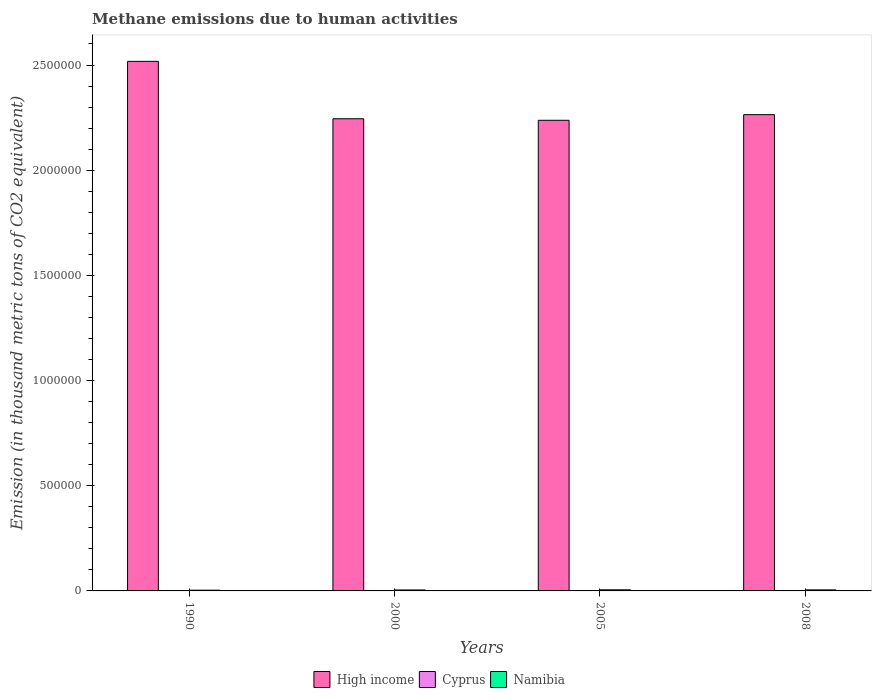How many different coloured bars are there?
Make the answer very short. 3. Are the number of bars per tick equal to the number of legend labels?
Keep it short and to the point. Yes. Are the number of bars on each tick of the X-axis equal?
Give a very brief answer. Yes. What is the label of the 4th group of bars from the left?
Your answer should be compact. 2008. In how many cases, is the number of bars for a given year not equal to the number of legend labels?
Provide a short and direct response. 0. What is the amount of methane emitted in Namibia in 2008?
Give a very brief answer. 4941.9. Across all years, what is the maximum amount of methane emitted in High income?
Your answer should be compact. 2.52e+06. Across all years, what is the minimum amount of methane emitted in High income?
Ensure brevity in your answer.  2.24e+06. In which year was the amount of methane emitted in Namibia minimum?
Provide a succinct answer. 1990. What is the total amount of methane emitted in Cyprus in the graph?
Make the answer very short. 2243.3. What is the difference between the amount of methane emitted in Namibia in 1990 and that in 2008?
Provide a succinct answer. -1388.4. What is the difference between the amount of methane emitted in Namibia in 2000 and the amount of methane emitted in Cyprus in 1990?
Keep it short and to the point. 4140.4. What is the average amount of methane emitted in Namibia per year?
Your answer should be very brief. 4582.1. In the year 2008, what is the difference between the amount of methane emitted in Cyprus and amount of methane emitted in High income?
Give a very brief answer. -2.26e+06. In how many years, is the amount of methane emitted in Namibia greater than 500000 thousand metric tons?
Make the answer very short. 0. What is the ratio of the amount of methane emitted in High income in 2000 to that in 2008?
Provide a succinct answer. 0.99. Is the amount of methane emitted in High income in 2000 less than that in 2008?
Ensure brevity in your answer.  Yes. What is the difference between the highest and the second highest amount of methane emitted in Cyprus?
Make the answer very short. 4.4. What is the difference between the highest and the lowest amount of methane emitted in Cyprus?
Offer a terse response. 177.3. In how many years, is the amount of methane emitted in High income greater than the average amount of methane emitted in High income taken over all years?
Give a very brief answer. 1. What does the 2nd bar from the left in 2008 represents?
Your response must be concise. Cyprus. What does the 3rd bar from the right in 2005 represents?
Provide a succinct answer. High income. How many bars are there?
Keep it short and to the point. 12. Are all the bars in the graph horizontal?
Provide a succinct answer. No. Are the values on the major ticks of Y-axis written in scientific E-notation?
Make the answer very short. No. Where does the legend appear in the graph?
Keep it short and to the point. Bottom center. How are the legend labels stacked?
Your answer should be very brief. Horizontal. What is the title of the graph?
Ensure brevity in your answer.  Methane emissions due to human activities. Does "Cabo Verde" appear as one of the legend labels in the graph?
Provide a succinct answer. No. What is the label or title of the Y-axis?
Offer a terse response. Emission (in thousand metric tons of CO2 equivalent). What is the Emission (in thousand metric tons of CO2 equivalent) of High income in 1990?
Your response must be concise. 2.52e+06. What is the Emission (in thousand metric tons of CO2 equivalent) of Cyprus in 1990?
Your response must be concise. 441.3. What is the Emission (in thousand metric tons of CO2 equivalent) in Namibia in 1990?
Ensure brevity in your answer.  3553.5. What is the Emission (in thousand metric tons of CO2 equivalent) of High income in 2000?
Your answer should be very brief. 2.24e+06. What is the Emission (in thousand metric tons of CO2 equivalent) in Cyprus in 2000?
Your answer should be compact. 569.2. What is the Emission (in thousand metric tons of CO2 equivalent) of Namibia in 2000?
Offer a terse response. 4581.7. What is the Emission (in thousand metric tons of CO2 equivalent) of High income in 2005?
Ensure brevity in your answer.  2.24e+06. What is the Emission (in thousand metric tons of CO2 equivalent) of Cyprus in 2005?
Make the answer very short. 618.6. What is the Emission (in thousand metric tons of CO2 equivalent) of Namibia in 2005?
Your answer should be very brief. 5251.3. What is the Emission (in thousand metric tons of CO2 equivalent) of High income in 2008?
Your answer should be compact. 2.26e+06. What is the Emission (in thousand metric tons of CO2 equivalent) of Cyprus in 2008?
Offer a terse response. 614.2. What is the Emission (in thousand metric tons of CO2 equivalent) in Namibia in 2008?
Provide a short and direct response. 4941.9. Across all years, what is the maximum Emission (in thousand metric tons of CO2 equivalent) of High income?
Offer a very short reply. 2.52e+06. Across all years, what is the maximum Emission (in thousand metric tons of CO2 equivalent) of Cyprus?
Your answer should be very brief. 618.6. Across all years, what is the maximum Emission (in thousand metric tons of CO2 equivalent) in Namibia?
Make the answer very short. 5251.3. Across all years, what is the minimum Emission (in thousand metric tons of CO2 equivalent) of High income?
Provide a short and direct response. 2.24e+06. Across all years, what is the minimum Emission (in thousand metric tons of CO2 equivalent) in Cyprus?
Offer a terse response. 441.3. Across all years, what is the minimum Emission (in thousand metric tons of CO2 equivalent) of Namibia?
Give a very brief answer. 3553.5. What is the total Emission (in thousand metric tons of CO2 equivalent) of High income in the graph?
Your answer should be very brief. 9.26e+06. What is the total Emission (in thousand metric tons of CO2 equivalent) in Cyprus in the graph?
Your answer should be compact. 2243.3. What is the total Emission (in thousand metric tons of CO2 equivalent) in Namibia in the graph?
Keep it short and to the point. 1.83e+04. What is the difference between the Emission (in thousand metric tons of CO2 equivalent) in High income in 1990 and that in 2000?
Provide a short and direct response. 2.73e+05. What is the difference between the Emission (in thousand metric tons of CO2 equivalent) in Cyprus in 1990 and that in 2000?
Offer a very short reply. -127.9. What is the difference between the Emission (in thousand metric tons of CO2 equivalent) in Namibia in 1990 and that in 2000?
Make the answer very short. -1028.2. What is the difference between the Emission (in thousand metric tons of CO2 equivalent) in High income in 1990 and that in 2005?
Give a very brief answer. 2.80e+05. What is the difference between the Emission (in thousand metric tons of CO2 equivalent) in Cyprus in 1990 and that in 2005?
Offer a very short reply. -177.3. What is the difference between the Emission (in thousand metric tons of CO2 equivalent) in Namibia in 1990 and that in 2005?
Offer a very short reply. -1697.8. What is the difference between the Emission (in thousand metric tons of CO2 equivalent) of High income in 1990 and that in 2008?
Provide a succinct answer. 2.53e+05. What is the difference between the Emission (in thousand metric tons of CO2 equivalent) of Cyprus in 1990 and that in 2008?
Your response must be concise. -172.9. What is the difference between the Emission (in thousand metric tons of CO2 equivalent) in Namibia in 1990 and that in 2008?
Provide a short and direct response. -1388.4. What is the difference between the Emission (in thousand metric tons of CO2 equivalent) of High income in 2000 and that in 2005?
Ensure brevity in your answer.  7311.3. What is the difference between the Emission (in thousand metric tons of CO2 equivalent) of Cyprus in 2000 and that in 2005?
Keep it short and to the point. -49.4. What is the difference between the Emission (in thousand metric tons of CO2 equivalent) of Namibia in 2000 and that in 2005?
Offer a very short reply. -669.6. What is the difference between the Emission (in thousand metric tons of CO2 equivalent) in High income in 2000 and that in 2008?
Provide a short and direct response. -1.95e+04. What is the difference between the Emission (in thousand metric tons of CO2 equivalent) in Cyprus in 2000 and that in 2008?
Your response must be concise. -45. What is the difference between the Emission (in thousand metric tons of CO2 equivalent) in Namibia in 2000 and that in 2008?
Keep it short and to the point. -360.2. What is the difference between the Emission (in thousand metric tons of CO2 equivalent) in High income in 2005 and that in 2008?
Provide a short and direct response. -2.68e+04. What is the difference between the Emission (in thousand metric tons of CO2 equivalent) in Cyprus in 2005 and that in 2008?
Offer a terse response. 4.4. What is the difference between the Emission (in thousand metric tons of CO2 equivalent) in Namibia in 2005 and that in 2008?
Provide a succinct answer. 309.4. What is the difference between the Emission (in thousand metric tons of CO2 equivalent) in High income in 1990 and the Emission (in thousand metric tons of CO2 equivalent) in Cyprus in 2000?
Keep it short and to the point. 2.52e+06. What is the difference between the Emission (in thousand metric tons of CO2 equivalent) in High income in 1990 and the Emission (in thousand metric tons of CO2 equivalent) in Namibia in 2000?
Give a very brief answer. 2.51e+06. What is the difference between the Emission (in thousand metric tons of CO2 equivalent) in Cyprus in 1990 and the Emission (in thousand metric tons of CO2 equivalent) in Namibia in 2000?
Offer a very short reply. -4140.4. What is the difference between the Emission (in thousand metric tons of CO2 equivalent) in High income in 1990 and the Emission (in thousand metric tons of CO2 equivalent) in Cyprus in 2005?
Give a very brief answer. 2.52e+06. What is the difference between the Emission (in thousand metric tons of CO2 equivalent) of High income in 1990 and the Emission (in thousand metric tons of CO2 equivalent) of Namibia in 2005?
Give a very brief answer. 2.51e+06. What is the difference between the Emission (in thousand metric tons of CO2 equivalent) in Cyprus in 1990 and the Emission (in thousand metric tons of CO2 equivalent) in Namibia in 2005?
Provide a succinct answer. -4810. What is the difference between the Emission (in thousand metric tons of CO2 equivalent) in High income in 1990 and the Emission (in thousand metric tons of CO2 equivalent) in Cyprus in 2008?
Provide a short and direct response. 2.52e+06. What is the difference between the Emission (in thousand metric tons of CO2 equivalent) of High income in 1990 and the Emission (in thousand metric tons of CO2 equivalent) of Namibia in 2008?
Your answer should be very brief. 2.51e+06. What is the difference between the Emission (in thousand metric tons of CO2 equivalent) of Cyprus in 1990 and the Emission (in thousand metric tons of CO2 equivalent) of Namibia in 2008?
Provide a short and direct response. -4500.6. What is the difference between the Emission (in thousand metric tons of CO2 equivalent) of High income in 2000 and the Emission (in thousand metric tons of CO2 equivalent) of Cyprus in 2005?
Keep it short and to the point. 2.24e+06. What is the difference between the Emission (in thousand metric tons of CO2 equivalent) of High income in 2000 and the Emission (in thousand metric tons of CO2 equivalent) of Namibia in 2005?
Provide a short and direct response. 2.24e+06. What is the difference between the Emission (in thousand metric tons of CO2 equivalent) of Cyprus in 2000 and the Emission (in thousand metric tons of CO2 equivalent) of Namibia in 2005?
Provide a short and direct response. -4682.1. What is the difference between the Emission (in thousand metric tons of CO2 equivalent) in High income in 2000 and the Emission (in thousand metric tons of CO2 equivalent) in Cyprus in 2008?
Make the answer very short. 2.24e+06. What is the difference between the Emission (in thousand metric tons of CO2 equivalent) in High income in 2000 and the Emission (in thousand metric tons of CO2 equivalent) in Namibia in 2008?
Make the answer very short. 2.24e+06. What is the difference between the Emission (in thousand metric tons of CO2 equivalent) of Cyprus in 2000 and the Emission (in thousand metric tons of CO2 equivalent) of Namibia in 2008?
Your answer should be compact. -4372.7. What is the difference between the Emission (in thousand metric tons of CO2 equivalent) of High income in 2005 and the Emission (in thousand metric tons of CO2 equivalent) of Cyprus in 2008?
Give a very brief answer. 2.24e+06. What is the difference between the Emission (in thousand metric tons of CO2 equivalent) of High income in 2005 and the Emission (in thousand metric tons of CO2 equivalent) of Namibia in 2008?
Offer a very short reply. 2.23e+06. What is the difference between the Emission (in thousand metric tons of CO2 equivalent) of Cyprus in 2005 and the Emission (in thousand metric tons of CO2 equivalent) of Namibia in 2008?
Make the answer very short. -4323.3. What is the average Emission (in thousand metric tons of CO2 equivalent) in High income per year?
Your answer should be compact. 2.32e+06. What is the average Emission (in thousand metric tons of CO2 equivalent) in Cyprus per year?
Your response must be concise. 560.83. What is the average Emission (in thousand metric tons of CO2 equivalent) in Namibia per year?
Your answer should be very brief. 4582.1. In the year 1990, what is the difference between the Emission (in thousand metric tons of CO2 equivalent) in High income and Emission (in thousand metric tons of CO2 equivalent) in Cyprus?
Your response must be concise. 2.52e+06. In the year 1990, what is the difference between the Emission (in thousand metric tons of CO2 equivalent) in High income and Emission (in thousand metric tons of CO2 equivalent) in Namibia?
Give a very brief answer. 2.51e+06. In the year 1990, what is the difference between the Emission (in thousand metric tons of CO2 equivalent) in Cyprus and Emission (in thousand metric tons of CO2 equivalent) in Namibia?
Give a very brief answer. -3112.2. In the year 2000, what is the difference between the Emission (in thousand metric tons of CO2 equivalent) of High income and Emission (in thousand metric tons of CO2 equivalent) of Cyprus?
Provide a succinct answer. 2.24e+06. In the year 2000, what is the difference between the Emission (in thousand metric tons of CO2 equivalent) in High income and Emission (in thousand metric tons of CO2 equivalent) in Namibia?
Your response must be concise. 2.24e+06. In the year 2000, what is the difference between the Emission (in thousand metric tons of CO2 equivalent) of Cyprus and Emission (in thousand metric tons of CO2 equivalent) of Namibia?
Your response must be concise. -4012.5. In the year 2005, what is the difference between the Emission (in thousand metric tons of CO2 equivalent) of High income and Emission (in thousand metric tons of CO2 equivalent) of Cyprus?
Make the answer very short. 2.24e+06. In the year 2005, what is the difference between the Emission (in thousand metric tons of CO2 equivalent) of High income and Emission (in thousand metric tons of CO2 equivalent) of Namibia?
Your answer should be very brief. 2.23e+06. In the year 2005, what is the difference between the Emission (in thousand metric tons of CO2 equivalent) in Cyprus and Emission (in thousand metric tons of CO2 equivalent) in Namibia?
Offer a terse response. -4632.7. In the year 2008, what is the difference between the Emission (in thousand metric tons of CO2 equivalent) of High income and Emission (in thousand metric tons of CO2 equivalent) of Cyprus?
Offer a terse response. 2.26e+06. In the year 2008, what is the difference between the Emission (in thousand metric tons of CO2 equivalent) of High income and Emission (in thousand metric tons of CO2 equivalent) of Namibia?
Ensure brevity in your answer.  2.26e+06. In the year 2008, what is the difference between the Emission (in thousand metric tons of CO2 equivalent) in Cyprus and Emission (in thousand metric tons of CO2 equivalent) in Namibia?
Ensure brevity in your answer.  -4327.7. What is the ratio of the Emission (in thousand metric tons of CO2 equivalent) in High income in 1990 to that in 2000?
Offer a very short reply. 1.12. What is the ratio of the Emission (in thousand metric tons of CO2 equivalent) of Cyprus in 1990 to that in 2000?
Make the answer very short. 0.78. What is the ratio of the Emission (in thousand metric tons of CO2 equivalent) in Namibia in 1990 to that in 2000?
Offer a terse response. 0.78. What is the ratio of the Emission (in thousand metric tons of CO2 equivalent) of High income in 1990 to that in 2005?
Your response must be concise. 1.13. What is the ratio of the Emission (in thousand metric tons of CO2 equivalent) in Cyprus in 1990 to that in 2005?
Give a very brief answer. 0.71. What is the ratio of the Emission (in thousand metric tons of CO2 equivalent) in Namibia in 1990 to that in 2005?
Your answer should be compact. 0.68. What is the ratio of the Emission (in thousand metric tons of CO2 equivalent) of High income in 1990 to that in 2008?
Your response must be concise. 1.11. What is the ratio of the Emission (in thousand metric tons of CO2 equivalent) in Cyprus in 1990 to that in 2008?
Ensure brevity in your answer.  0.72. What is the ratio of the Emission (in thousand metric tons of CO2 equivalent) of Namibia in 1990 to that in 2008?
Provide a short and direct response. 0.72. What is the ratio of the Emission (in thousand metric tons of CO2 equivalent) in High income in 2000 to that in 2005?
Provide a succinct answer. 1. What is the ratio of the Emission (in thousand metric tons of CO2 equivalent) in Cyprus in 2000 to that in 2005?
Your response must be concise. 0.92. What is the ratio of the Emission (in thousand metric tons of CO2 equivalent) of Namibia in 2000 to that in 2005?
Make the answer very short. 0.87. What is the ratio of the Emission (in thousand metric tons of CO2 equivalent) in High income in 2000 to that in 2008?
Provide a succinct answer. 0.99. What is the ratio of the Emission (in thousand metric tons of CO2 equivalent) of Cyprus in 2000 to that in 2008?
Your answer should be very brief. 0.93. What is the ratio of the Emission (in thousand metric tons of CO2 equivalent) of Namibia in 2000 to that in 2008?
Provide a short and direct response. 0.93. What is the ratio of the Emission (in thousand metric tons of CO2 equivalent) in Cyprus in 2005 to that in 2008?
Give a very brief answer. 1.01. What is the ratio of the Emission (in thousand metric tons of CO2 equivalent) in Namibia in 2005 to that in 2008?
Your response must be concise. 1.06. What is the difference between the highest and the second highest Emission (in thousand metric tons of CO2 equivalent) of High income?
Give a very brief answer. 2.53e+05. What is the difference between the highest and the second highest Emission (in thousand metric tons of CO2 equivalent) in Namibia?
Provide a succinct answer. 309.4. What is the difference between the highest and the lowest Emission (in thousand metric tons of CO2 equivalent) in High income?
Offer a terse response. 2.80e+05. What is the difference between the highest and the lowest Emission (in thousand metric tons of CO2 equivalent) of Cyprus?
Offer a terse response. 177.3. What is the difference between the highest and the lowest Emission (in thousand metric tons of CO2 equivalent) in Namibia?
Your answer should be compact. 1697.8. 